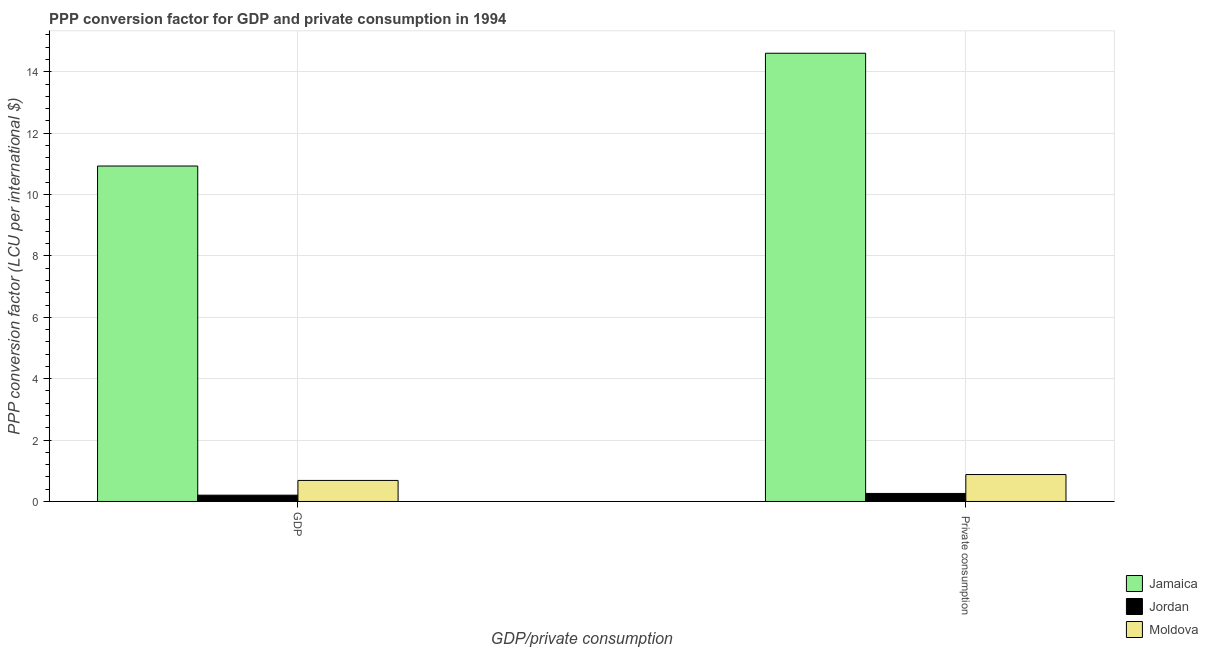How many different coloured bars are there?
Your response must be concise. 3. Are the number of bars per tick equal to the number of legend labels?
Your response must be concise. Yes. What is the label of the 1st group of bars from the left?
Make the answer very short. GDP. What is the ppp conversion factor for private consumption in Jamaica?
Your answer should be compact. 14.6. Across all countries, what is the maximum ppp conversion factor for private consumption?
Your answer should be very brief. 14.6. Across all countries, what is the minimum ppp conversion factor for private consumption?
Ensure brevity in your answer.  0.26. In which country was the ppp conversion factor for gdp maximum?
Offer a terse response. Jamaica. In which country was the ppp conversion factor for private consumption minimum?
Offer a very short reply. Jordan. What is the total ppp conversion factor for private consumption in the graph?
Offer a very short reply. 15.74. What is the difference between the ppp conversion factor for private consumption in Moldova and that in Jordan?
Offer a terse response. 0.62. What is the difference between the ppp conversion factor for private consumption in Moldova and the ppp conversion factor for gdp in Jamaica?
Offer a very short reply. -10.05. What is the average ppp conversion factor for private consumption per country?
Provide a succinct answer. 5.25. What is the difference between the ppp conversion factor for private consumption and ppp conversion factor for gdp in Moldova?
Your response must be concise. 0.19. In how many countries, is the ppp conversion factor for private consumption greater than 6.4 LCU?
Offer a terse response. 1. What is the ratio of the ppp conversion factor for private consumption in Jamaica to that in Moldova?
Offer a terse response. 16.64. Is the ppp conversion factor for gdp in Moldova less than that in Jordan?
Your answer should be compact. No. In how many countries, is the ppp conversion factor for gdp greater than the average ppp conversion factor for gdp taken over all countries?
Ensure brevity in your answer.  1. What does the 3rd bar from the left in  Private consumption represents?
Provide a succinct answer. Moldova. What does the 3rd bar from the right in GDP represents?
Offer a very short reply. Jamaica. Are all the bars in the graph horizontal?
Keep it short and to the point. No. How many countries are there in the graph?
Your answer should be compact. 3. Where does the legend appear in the graph?
Give a very brief answer. Bottom right. How are the legend labels stacked?
Provide a succinct answer. Vertical. What is the title of the graph?
Your response must be concise. PPP conversion factor for GDP and private consumption in 1994. What is the label or title of the X-axis?
Make the answer very short. GDP/private consumption. What is the label or title of the Y-axis?
Give a very brief answer. PPP conversion factor (LCU per international $). What is the PPP conversion factor (LCU per international $) of Jamaica in GDP?
Your answer should be very brief. 10.93. What is the PPP conversion factor (LCU per international $) in Jordan in GDP?
Offer a terse response. 0.21. What is the PPP conversion factor (LCU per international $) in Moldova in GDP?
Give a very brief answer. 0.69. What is the PPP conversion factor (LCU per international $) of Jamaica in  Private consumption?
Provide a short and direct response. 14.6. What is the PPP conversion factor (LCU per international $) in Jordan in  Private consumption?
Your response must be concise. 0.26. What is the PPP conversion factor (LCU per international $) in Moldova in  Private consumption?
Your answer should be compact. 0.88. Across all GDP/private consumption, what is the maximum PPP conversion factor (LCU per international $) in Jamaica?
Offer a very short reply. 14.6. Across all GDP/private consumption, what is the maximum PPP conversion factor (LCU per international $) in Jordan?
Ensure brevity in your answer.  0.26. Across all GDP/private consumption, what is the maximum PPP conversion factor (LCU per international $) in Moldova?
Provide a succinct answer. 0.88. Across all GDP/private consumption, what is the minimum PPP conversion factor (LCU per international $) of Jamaica?
Ensure brevity in your answer.  10.93. Across all GDP/private consumption, what is the minimum PPP conversion factor (LCU per international $) of Jordan?
Ensure brevity in your answer.  0.21. Across all GDP/private consumption, what is the minimum PPP conversion factor (LCU per international $) in Moldova?
Offer a terse response. 0.69. What is the total PPP conversion factor (LCU per international $) of Jamaica in the graph?
Your response must be concise. 25.53. What is the total PPP conversion factor (LCU per international $) in Jordan in the graph?
Ensure brevity in your answer.  0.47. What is the total PPP conversion factor (LCU per international $) in Moldova in the graph?
Provide a short and direct response. 1.56. What is the difference between the PPP conversion factor (LCU per international $) in Jamaica in GDP and that in  Private consumption?
Provide a short and direct response. -3.67. What is the difference between the PPP conversion factor (LCU per international $) of Jordan in GDP and that in  Private consumption?
Keep it short and to the point. -0.06. What is the difference between the PPP conversion factor (LCU per international $) in Moldova in GDP and that in  Private consumption?
Your answer should be very brief. -0.19. What is the difference between the PPP conversion factor (LCU per international $) of Jamaica in GDP and the PPP conversion factor (LCU per international $) of Jordan in  Private consumption?
Ensure brevity in your answer.  10.67. What is the difference between the PPP conversion factor (LCU per international $) of Jamaica in GDP and the PPP conversion factor (LCU per international $) of Moldova in  Private consumption?
Offer a terse response. 10.05. What is the difference between the PPP conversion factor (LCU per international $) of Jordan in GDP and the PPP conversion factor (LCU per international $) of Moldova in  Private consumption?
Your answer should be very brief. -0.67. What is the average PPP conversion factor (LCU per international $) in Jamaica per GDP/private consumption?
Offer a terse response. 12.77. What is the average PPP conversion factor (LCU per international $) in Jordan per GDP/private consumption?
Your response must be concise. 0.23. What is the average PPP conversion factor (LCU per international $) in Moldova per GDP/private consumption?
Make the answer very short. 0.78. What is the difference between the PPP conversion factor (LCU per international $) in Jamaica and PPP conversion factor (LCU per international $) in Jordan in GDP?
Provide a succinct answer. 10.72. What is the difference between the PPP conversion factor (LCU per international $) in Jamaica and PPP conversion factor (LCU per international $) in Moldova in GDP?
Keep it short and to the point. 10.24. What is the difference between the PPP conversion factor (LCU per international $) in Jordan and PPP conversion factor (LCU per international $) in Moldova in GDP?
Provide a succinct answer. -0.48. What is the difference between the PPP conversion factor (LCU per international $) in Jamaica and PPP conversion factor (LCU per international $) in Jordan in  Private consumption?
Give a very brief answer. 14.34. What is the difference between the PPP conversion factor (LCU per international $) in Jamaica and PPP conversion factor (LCU per international $) in Moldova in  Private consumption?
Ensure brevity in your answer.  13.73. What is the difference between the PPP conversion factor (LCU per international $) in Jordan and PPP conversion factor (LCU per international $) in Moldova in  Private consumption?
Offer a terse response. -0.62. What is the ratio of the PPP conversion factor (LCU per international $) of Jamaica in GDP to that in  Private consumption?
Your response must be concise. 0.75. What is the ratio of the PPP conversion factor (LCU per international $) of Jordan in GDP to that in  Private consumption?
Give a very brief answer. 0.79. What is the ratio of the PPP conversion factor (LCU per international $) in Moldova in GDP to that in  Private consumption?
Offer a very short reply. 0.78. What is the difference between the highest and the second highest PPP conversion factor (LCU per international $) in Jamaica?
Give a very brief answer. 3.67. What is the difference between the highest and the second highest PPP conversion factor (LCU per international $) in Jordan?
Keep it short and to the point. 0.06. What is the difference between the highest and the second highest PPP conversion factor (LCU per international $) of Moldova?
Provide a short and direct response. 0.19. What is the difference between the highest and the lowest PPP conversion factor (LCU per international $) of Jamaica?
Your answer should be very brief. 3.67. What is the difference between the highest and the lowest PPP conversion factor (LCU per international $) of Jordan?
Offer a very short reply. 0.06. What is the difference between the highest and the lowest PPP conversion factor (LCU per international $) in Moldova?
Offer a very short reply. 0.19. 